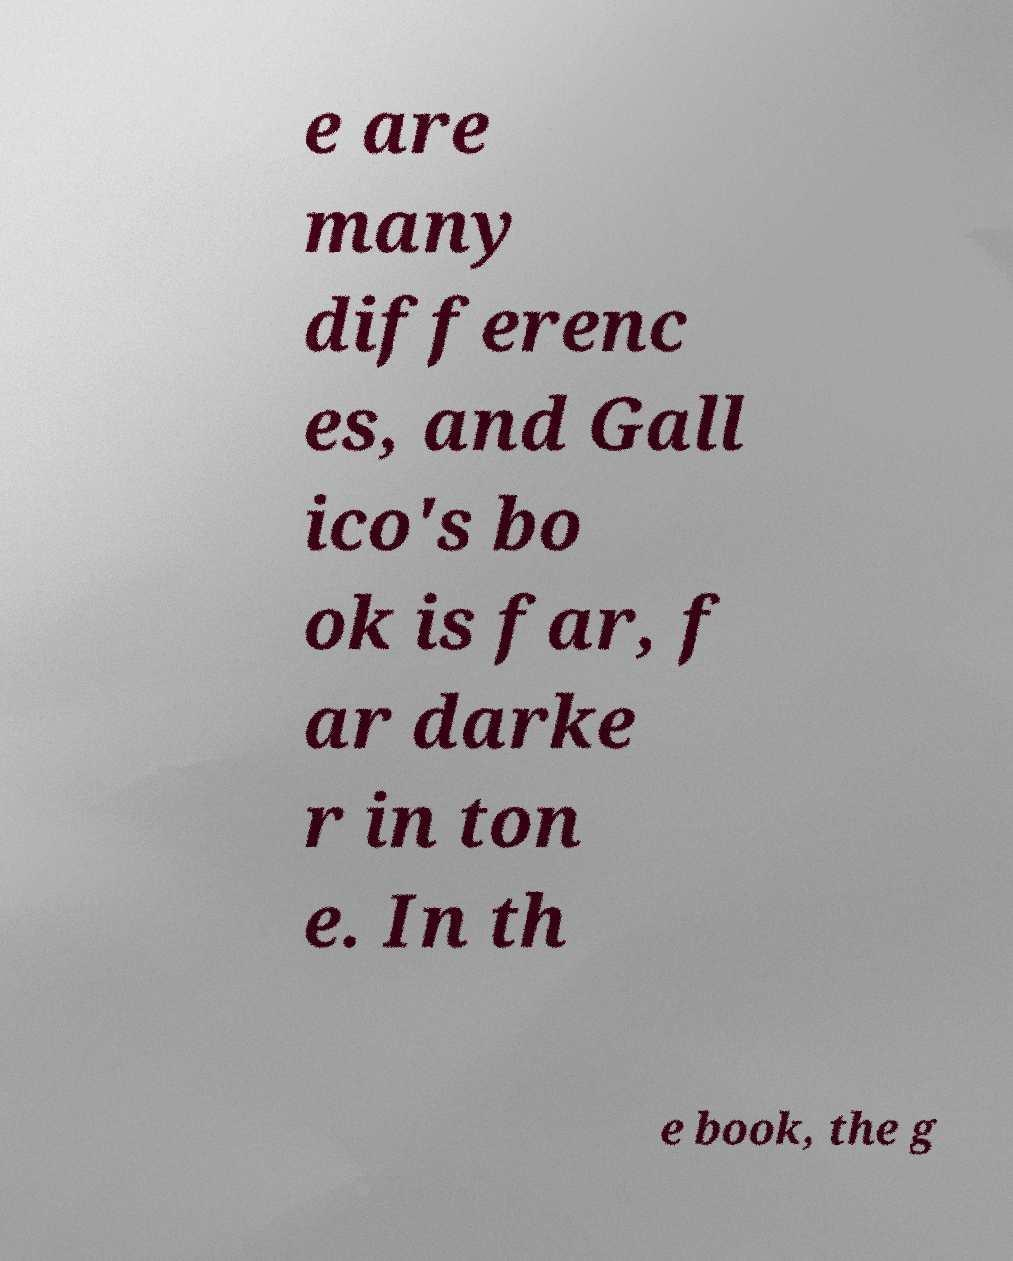For documentation purposes, I need the text within this image transcribed. Could you provide that? e are many differenc es, and Gall ico's bo ok is far, f ar darke r in ton e. In th e book, the g 